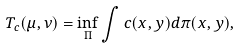Convert formula to latex. <formula><loc_0><loc_0><loc_500><loc_500>T _ { c } ( \mu , \nu ) = \inf _ { \Pi } \int c ( x , y ) d \pi ( x , y ) ,</formula> 